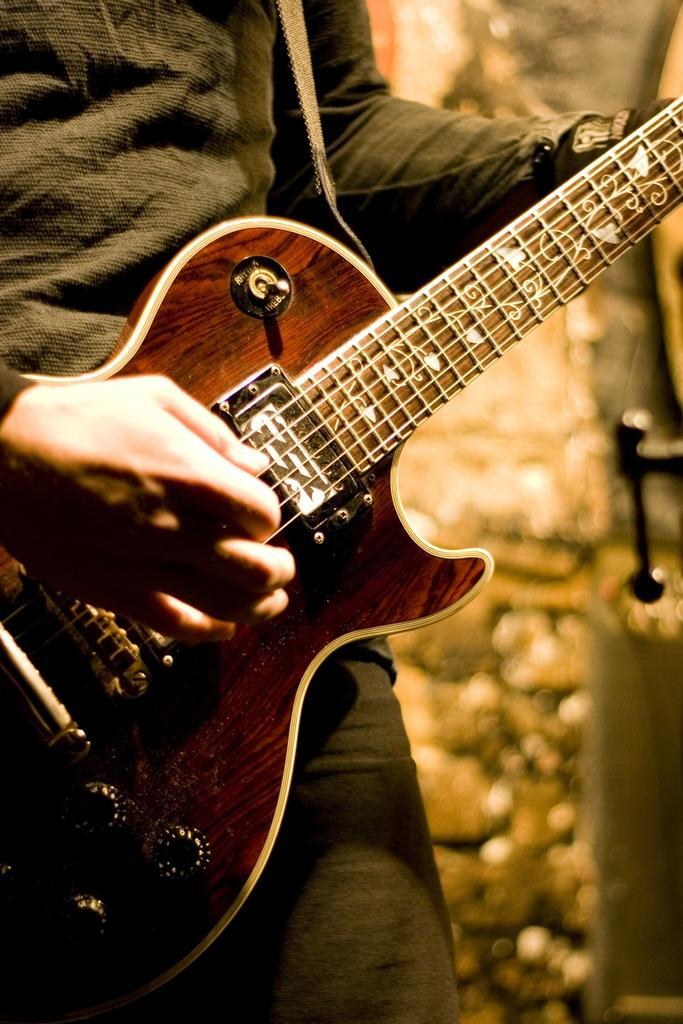How would you summarize this image in a sentence or two? In this image there is a person holding a guitar. 